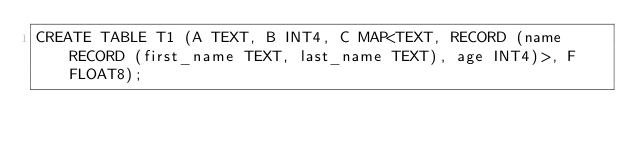<code> <loc_0><loc_0><loc_500><loc_500><_SQL_>CREATE TABLE T1 (A TEXT, B INT4, C MAP<TEXT, RECORD (name RECORD (first_name TEXT, last_name TEXT), age INT4)>, F FLOAT8);</code> 